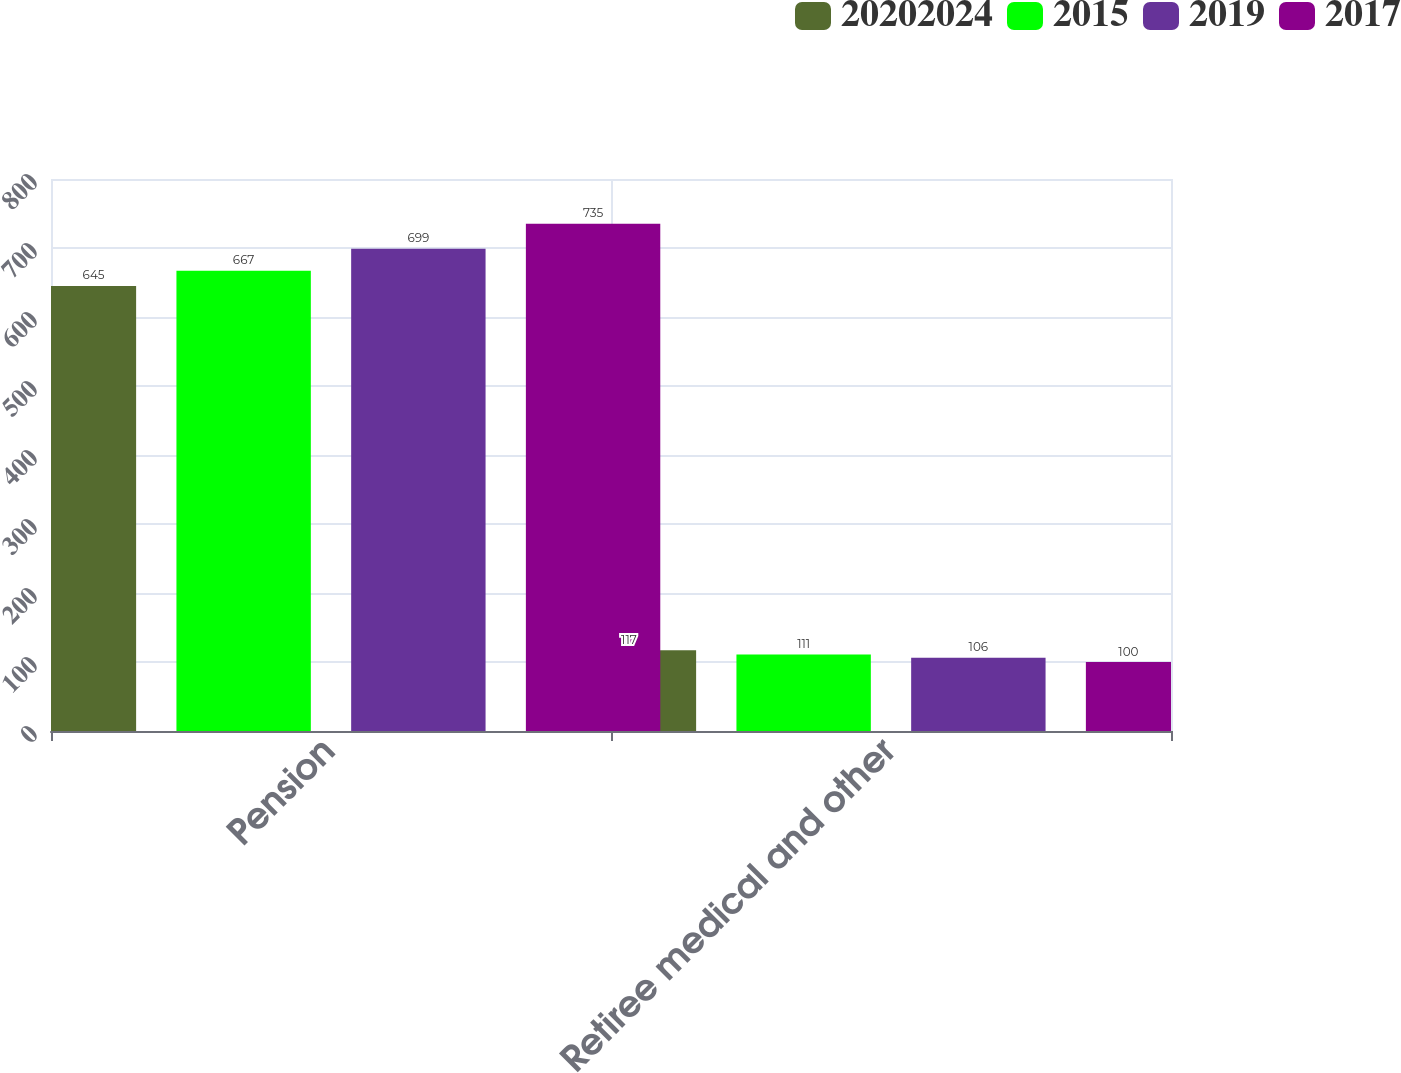Convert chart to OTSL. <chart><loc_0><loc_0><loc_500><loc_500><stacked_bar_chart><ecel><fcel>Pension<fcel>Retiree medical and other<nl><fcel>2.0202e+07<fcel>645<fcel>117<nl><fcel>2015<fcel>667<fcel>111<nl><fcel>2019<fcel>699<fcel>106<nl><fcel>2017<fcel>735<fcel>100<nl></chart> 